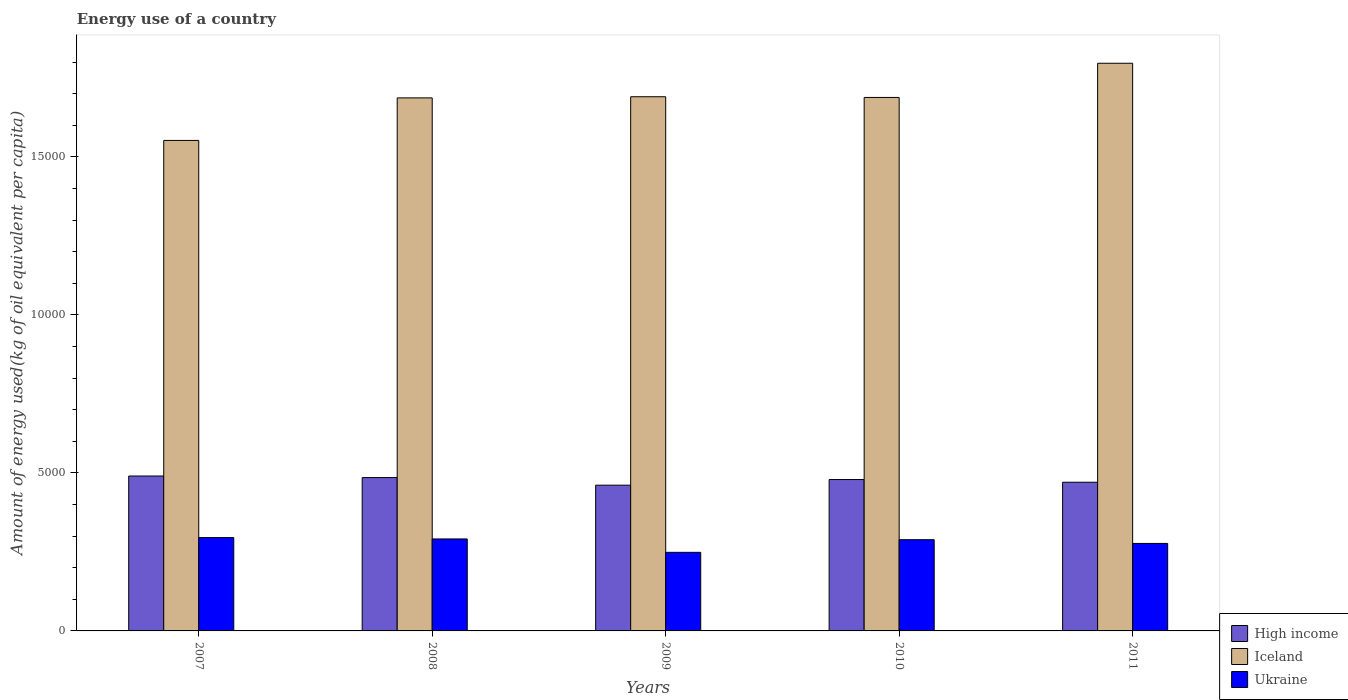How many different coloured bars are there?
Your response must be concise. 3. How many groups of bars are there?
Ensure brevity in your answer.  5. What is the label of the 1st group of bars from the left?
Offer a terse response. 2007. What is the amount of energy used in in High income in 2010?
Give a very brief answer. 4790.88. Across all years, what is the maximum amount of energy used in in High income?
Ensure brevity in your answer.  4902.25. Across all years, what is the minimum amount of energy used in in High income?
Provide a succinct answer. 4612.03. What is the total amount of energy used in in Ukraine in the graph?
Give a very brief answer. 1.40e+04. What is the difference between the amount of energy used in in High income in 2007 and that in 2010?
Provide a short and direct response. 111.37. What is the difference between the amount of energy used in in Iceland in 2011 and the amount of energy used in in Ukraine in 2007?
Make the answer very short. 1.50e+04. What is the average amount of energy used in in Ukraine per year?
Your answer should be very brief. 2801.32. In the year 2008, what is the difference between the amount of energy used in in High income and amount of energy used in in Ukraine?
Give a very brief answer. 1942.06. In how many years, is the amount of energy used in in High income greater than 15000 kg?
Provide a short and direct response. 0. What is the ratio of the amount of energy used in in High income in 2008 to that in 2011?
Make the answer very short. 1.03. Is the amount of energy used in in Iceland in 2007 less than that in 2010?
Your answer should be very brief. Yes. What is the difference between the highest and the second highest amount of energy used in in High income?
Provide a short and direct response. 49.54. What is the difference between the highest and the lowest amount of energy used in in Iceland?
Give a very brief answer. 2442.29. Is the sum of the amount of energy used in in Iceland in 2010 and 2011 greater than the maximum amount of energy used in in Ukraine across all years?
Your answer should be very brief. Yes. What does the 2nd bar from the left in 2009 represents?
Provide a short and direct response. Iceland. What does the 3rd bar from the right in 2009 represents?
Offer a very short reply. High income. Is it the case that in every year, the sum of the amount of energy used in in Ukraine and amount of energy used in in Iceland is greater than the amount of energy used in in High income?
Give a very brief answer. Yes. How many bars are there?
Give a very brief answer. 15. Are all the bars in the graph horizontal?
Your response must be concise. No. What is the difference between two consecutive major ticks on the Y-axis?
Provide a short and direct response. 5000. Are the values on the major ticks of Y-axis written in scientific E-notation?
Your answer should be compact. No. What is the title of the graph?
Ensure brevity in your answer.  Energy use of a country. What is the label or title of the Y-axis?
Offer a very short reply. Amount of energy used(kg of oil equivalent per capita). What is the Amount of energy used(kg of oil equivalent per capita) in High income in 2007?
Your answer should be very brief. 4902.25. What is the Amount of energy used(kg of oil equivalent per capita) in Iceland in 2007?
Keep it short and to the point. 1.55e+04. What is the Amount of energy used(kg of oil equivalent per capita) in Ukraine in 2007?
Your answer should be compact. 2953.02. What is the Amount of energy used(kg of oil equivalent per capita) of High income in 2008?
Provide a short and direct response. 4852.71. What is the Amount of energy used(kg of oil equivalent per capita) in Iceland in 2008?
Provide a short and direct response. 1.69e+04. What is the Amount of energy used(kg of oil equivalent per capita) of Ukraine in 2008?
Your answer should be very brief. 2910.65. What is the Amount of energy used(kg of oil equivalent per capita) in High income in 2009?
Offer a terse response. 4612.03. What is the Amount of energy used(kg of oil equivalent per capita) of Iceland in 2009?
Your response must be concise. 1.69e+04. What is the Amount of energy used(kg of oil equivalent per capita) in Ukraine in 2009?
Offer a terse response. 2487.04. What is the Amount of energy used(kg of oil equivalent per capita) of High income in 2010?
Keep it short and to the point. 4790.88. What is the Amount of energy used(kg of oil equivalent per capita) of Iceland in 2010?
Your response must be concise. 1.69e+04. What is the Amount of energy used(kg of oil equivalent per capita) in Ukraine in 2010?
Make the answer very short. 2887. What is the Amount of energy used(kg of oil equivalent per capita) of High income in 2011?
Provide a short and direct response. 4705.29. What is the Amount of energy used(kg of oil equivalent per capita) in Iceland in 2011?
Keep it short and to the point. 1.80e+04. What is the Amount of energy used(kg of oil equivalent per capita) of Ukraine in 2011?
Your response must be concise. 2768.92. Across all years, what is the maximum Amount of energy used(kg of oil equivalent per capita) in High income?
Your answer should be very brief. 4902.25. Across all years, what is the maximum Amount of energy used(kg of oil equivalent per capita) in Iceland?
Provide a succinct answer. 1.80e+04. Across all years, what is the maximum Amount of energy used(kg of oil equivalent per capita) of Ukraine?
Provide a succinct answer. 2953.02. Across all years, what is the minimum Amount of energy used(kg of oil equivalent per capita) in High income?
Your response must be concise. 4612.03. Across all years, what is the minimum Amount of energy used(kg of oil equivalent per capita) of Iceland?
Provide a succinct answer. 1.55e+04. Across all years, what is the minimum Amount of energy used(kg of oil equivalent per capita) of Ukraine?
Make the answer very short. 2487.04. What is the total Amount of energy used(kg of oil equivalent per capita) of High income in the graph?
Provide a short and direct response. 2.39e+04. What is the total Amount of energy used(kg of oil equivalent per capita) of Iceland in the graph?
Provide a succinct answer. 8.41e+04. What is the total Amount of energy used(kg of oil equivalent per capita) of Ukraine in the graph?
Provide a short and direct response. 1.40e+04. What is the difference between the Amount of energy used(kg of oil equivalent per capita) of High income in 2007 and that in 2008?
Your response must be concise. 49.54. What is the difference between the Amount of energy used(kg of oil equivalent per capita) of Iceland in 2007 and that in 2008?
Offer a terse response. -1346.32. What is the difference between the Amount of energy used(kg of oil equivalent per capita) of Ukraine in 2007 and that in 2008?
Your answer should be very brief. 42.36. What is the difference between the Amount of energy used(kg of oil equivalent per capita) of High income in 2007 and that in 2009?
Your answer should be compact. 290.21. What is the difference between the Amount of energy used(kg of oil equivalent per capita) in Iceland in 2007 and that in 2009?
Offer a very short reply. -1382.75. What is the difference between the Amount of energy used(kg of oil equivalent per capita) in Ukraine in 2007 and that in 2009?
Your answer should be very brief. 465.98. What is the difference between the Amount of energy used(kg of oil equivalent per capita) of High income in 2007 and that in 2010?
Offer a very short reply. 111.37. What is the difference between the Amount of energy used(kg of oil equivalent per capita) in Iceland in 2007 and that in 2010?
Your answer should be very brief. -1360.35. What is the difference between the Amount of energy used(kg of oil equivalent per capita) in Ukraine in 2007 and that in 2010?
Provide a short and direct response. 66.02. What is the difference between the Amount of energy used(kg of oil equivalent per capita) in High income in 2007 and that in 2011?
Provide a short and direct response. 196.96. What is the difference between the Amount of energy used(kg of oil equivalent per capita) in Iceland in 2007 and that in 2011?
Your response must be concise. -2442.29. What is the difference between the Amount of energy used(kg of oil equivalent per capita) of Ukraine in 2007 and that in 2011?
Give a very brief answer. 184.09. What is the difference between the Amount of energy used(kg of oil equivalent per capita) of High income in 2008 and that in 2009?
Your answer should be very brief. 240.68. What is the difference between the Amount of energy used(kg of oil equivalent per capita) of Iceland in 2008 and that in 2009?
Provide a short and direct response. -36.44. What is the difference between the Amount of energy used(kg of oil equivalent per capita) in Ukraine in 2008 and that in 2009?
Provide a short and direct response. 423.61. What is the difference between the Amount of energy used(kg of oil equivalent per capita) in High income in 2008 and that in 2010?
Your answer should be very brief. 61.83. What is the difference between the Amount of energy used(kg of oil equivalent per capita) in Iceland in 2008 and that in 2010?
Give a very brief answer. -14.03. What is the difference between the Amount of energy used(kg of oil equivalent per capita) of Ukraine in 2008 and that in 2010?
Keep it short and to the point. 23.66. What is the difference between the Amount of energy used(kg of oil equivalent per capita) of High income in 2008 and that in 2011?
Your answer should be compact. 147.42. What is the difference between the Amount of energy used(kg of oil equivalent per capita) of Iceland in 2008 and that in 2011?
Offer a terse response. -1095.98. What is the difference between the Amount of energy used(kg of oil equivalent per capita) of Ukraine in 2008 and that in 2011?
Provide a succinct answer. 141.73. What is the difference between the Amount of energy used(kg of oil equivalent per capita) in High income in 2009 and that in 2010?
Your answer should be compact. -178.84. What is the difference between the Amount of energy used(kg of oil equivalent per capita) in Iceland in 2009 and that in 2010?
Offer a very short reply. 22.4. What is the difference between the Amount of energy used(kg of oil equivalent per capita) of Ukraine in 2009 and that in 2010?
Give a very brief answer. -399.96. What is the difference between the Amount of energy used(kg of oil equivalent per capita) in High income in 2009 and that in 2011?
Give a very brief answer. -93.26. What is the difference between the Amount of energy used(kg of oil equivalent per capita) of Iceland in 2009 and that in 2011?
Make the answer very short. -1059.54. What is the difference between the Amount of energy used(kg of oil equivalent per capita) of Ukraine in 2009 and that in 2011?
Your response must be concise. -281.89. What is the difference between the Amount of energy used(kg of oil equivalent per capita) of High income in 2010 and that in 2011?
Provide a succinct answer. 85.58. What is the difference between the Amount of energy used(kg of oil equivalent per capita) of Iceland in 2010 and that in 2011?
Your response must be concise. -1081.94. What is the difference between the Amount of energy used(kg of oil equivalent per capita) of Ukraine in 2010 and that in 2011?
Ensure brevity in your answer.  118.07. What is the difference between the Amount of energy used(kg of oil equivalent per capita) in High income in 2007 and the Amount of energy used(kg of oil equivalent per capita) in Iceland in 2008?
Offer a terse response. -1.20e+04. What is the difference between the Amount of energy used(kg of oil equivalent per capita) of High income in 2007 and the Amount of energy used(kg of oil equivalent per capita) of Ukraine in 2008?
Give a very brief answer. 1991.59. What is the difference between the Amount of energy used(kg of oil equivalent per capita) in Iceland in 2007 and the Amount of energy used(kg of oil equivalent per capita) in Ukraine in 2008?
Your response must be concise. 1.26e+04. What is the difference between the Amount of energy used(kg of oil equivalent per capita) in High income in 2007 and the Amount of energy used(kg of oil equivalent per capita) in Iceland in 2009?
Ensure brevity in your answer.  -1.20e+04. What is the difference between the Amount of energy used(kg of oil equivalent per capita) in High income in 2007 and the Amount of energy used(kg of oil equivalent per capita) in Ukraine in 2009?
Your answer should be compact. 2415.21. What is the difference between the Amount of energy used(kg of oil equivalent per capita) of Iceland in 2007 and the Amount of energy used(kg of oil equivalent per capita) of Ukraine in 2009?
Provide a succinct answer. 1.30e+04. What is the difference between the Amount of energy used(kg of oil equivalent per capita) of High income in 2007 and the Amount of energy used(kg of oil equivalent per capita) of Iceland in 2010?
Ensure brevity in your answer.  -1.20e+04. What is the difference between the Amount of energy used(kg of oil equivalent per capita) in High income in 2007 and the Amount of energy used(kg of oil equivalent per capita) in Ukraine in 2010?
Your answer should be very brief. 2015.25. What is the difference between the Amount of energy used(kg of oil equivalent per capita) of Iceland in 2007 and the Amount of energy used(kg of oil equivalent per capita) of Ukraine in 2010?
Your answer should be compact. 1.26e+04. What is the difference between the Amount of energy used(kg of oil equivalent per capita) in High income in 2007 and the Amount of energy used(kg of oil equivalent per capita) in Iceland in 2011?
Provide a succinct answer. -1.31e+04. What is the difference between the Amount of energy used(kg of oil equivalent per capita) of High income in 2007 and the Amount of energy used(kg of oil equivalent per capita) of Ukraine in 2011?
Offer a very short reply. 2133.32. What is the difference between the Amount of energy used(kg of oil equivalent per capita) of Iceland in 2007 and the Amount of energy used(kg of oil equivalent per capita) of Ukraine in 2011?
Provide a succinct answer. 1.28e+04. What is the difference between the Amount of energy used(kg of oil equivalent per capita) of High income in 2008 and the Amount of energy used(kg of oil equivalent per capita) of Iceland in 2009?
Your answer should be compact. -1.21e+04. What is the difference between the Amount of energy used(kg of oil equivalent per capita) in High income in 2008 and the Amount of energy used(kg of oil equivalent per capita) in Ukraine in 2009?
Your answer should be very brief. 2365.67. What is the difference between the Amount of energy used(kg of oil equivalent per capita) of Iceland in 2008 and the Amount of energy used(kg of oil equivalent per capita) of Ukraine in 2009?
Give a very brief answer. 1.44e+04. What is the difference between the Amount of energy used(kg of oil equivalent per capita) in High income in 2008 and the Amount of energy used(kg of oil equivalent per capita) in Iceland in 2010?
Your answer should be compact. -1.20e+04. What is the difference between the Amount of energy used(kg of oil equivalent per capita) in High income in 2008 and the Amount of energy used(kg of oil equivalent per capita) in Ukraine in 2010?
Your answer should be compact. 1965.71. What is the difference between the Amount of energy used(kg of oil equivalent per capita) of Iceland in 2008 and the Amount of energy used(kg of oil equivalent per capita) of Ukraine in 2010?
Your response must be concise. 1.40e+04. What is the difference between the Amount of energy used(kg of oil equivalent per capita) of High income in 2008 and the Amount of energy used(kg of oil equivalent per capita) of Iceland in 2011?
Offer a terse response. -1.31e+04. What is the difference between the Amount of energy used(kg of oil equivalent per capita) of High income in 2008 and the Amount of energy used(kg of oil equivalent per capita) of Ukraine in 2011?
Your response must be concise. 2083.78. What is the difference between the Amount of energy used(kg of oil equivalent per capita) of Iceland in 2008 and the Amount of energy used(kg of oil equivalent per capita) of Ukraine in 2011?
Provide a short and direct response. 1.41e+04. What is the difference between the Amount of energy used(kg of oil equivalent per capita) in High income in 2009 and the Amount of energy used(kg of oil equivalent per capita) in Iceland in 2010?
Ensure brevity in your answer.  -1.23e+04. What is the difference between the Amount of energy used(kg of oil equivalent per capita) in High income in 2009 and the Amount of energy used(kg of oil equivalent per capita) in Ukraine in 2010?
Give a very brief answer. 1725.03. What is the difference between the Amount of energy used(kg of oil equivalent per capita) of Iceland in 2009 and the Amount of energy used(kg of oil equivalent per capita) of Ukraine in 2010?
Your answer should be very brief. 1.40e+04. What is the difference between the Amount of energy used(kg of oil equivalent per capita) in High income in 2009 and the Amount of energy used(kg of oil equivalent per capita) in Iceland in 2011?
Give a very brief answer. -1.34e+04. What is the difference between the Amount of energy used(kg of oil equivalent per capita) in High income in 2009 and the Amount of energy used(kg of oil equivalent per capita) in Ukraine in 2011?
Your answer should be very brief. 1843.11. What is the difference between the Amount of energy used(kg of oil equivalent per capita) of Iceland in 2009 and the Amount of energy used(kg of oil equivalent per capita) of Ukraine in 2011?
Give a very brief answer. 1.41e+04. What is the difference between the Amount of energy used(kg of oil equivalent per capita) of High income in 2010 and the Amount of energy used(kg of oil equivalent per capita) of Iceland in 2011?
Offer a terse response. -1.32e+04. What is the difference between the Amount of energy used(kg of oil equivalent per capita) in High income in 2010 and the Amount of energy used(kg of oil equivalent per capita) in Ukraine in 2011?
Offer a terse response. 2021.95. What is the difference between the Amount of energy used(kg of oil equivalent per capita) in Iceland in 2010 and the Amount of energy used(kg of oil equivalent per capita) in Ukraine in 2011?
Provide a succinct answer. 1.41e+04. What is the average Amount of energy used(kg of oil equivalent per capita) in High income per year?
Offer a terse response. 4772.63. What is the average Amount of energy used(kg of oil equivalent per capita) in Iceland per year?
Offer a terse response. 1.68e+04. What is the average Amount of energy used(kg of oil equivalent per capita) in Ukraine per year?
Offer a very short reply. 2801.32. In the year 2007, what is the difference between the Amount of energy used(kg of oil equivalent per capita) of High income and Amount of energy used(kg of oil equivalent per capita) of Iceland?
Provide a succinct answer. -1.06e+04. In the year 2007, what is the difference between the Amount of energy used(kg of oil equivalent per capita) of High income and Amount of energy used(kg of oil equivalent per capita) of Ukraine?
Provide a succinct answer. 1949.23. In the year 2007, what is the difference between the Amount of energy used(kg of oil equivalent per capita) in Iceland and Amount of energy used(kg of oil equivalent per capita) in Ukraine?
Offer a terse response. 1.26e+04. In the year 2008, what is the difference between the Amount of energy used(kg of oil equivalent per capita) of High income and Amount of energy used(kg of oil equivalent per capita) of Iceland?
Make the answer very short. -1.20e+04. In the year 2008, what is the difference between the Amount of energy used(kg of oil equivalent per capita) in High income and Amount of energy used(kg of oil equivalent per capita) in Ukraine?
Provide a succinct answer. 1942.06. In the year 2008, what is the difference between the Amount of energy used(kg of oil equivalent per capita) of Iceland and Amount of energy used(kg of oil equivalent per capita) of Ukraine?
Your answer should be compact. 1.40e+04. In the year 2009, what is the difference between the Amount of energy used(kg of oil equivalent per capita) of High income and Amount of energy used(kg of oil equivalent per capita) of Iceland?
Make the answer very short. -1.23e+04. In the year 2009, what is the difference between the Amount of energy used(kg of oil equivalent per capita) in High income and Amount of energy used(kg of oil equivalent per capita) in Ukraine?
Offer a terse response. 2124.99. In the year 2009, what is the difference between the Amount of energy used(kg of oil equivalent per capita) of Iceland and Amount of energy used(kg of oil equivalent per capita) of Ukraine?
Offer a terse response. 1.44e+04. In the year 2010, what is the difference between the Amount of energy used(kg of oil equivalent per capita) in High income and Amount of energy used(kg of oil equivalent per capita) in Iceland?
Provide a short and direct response. -1.21e+04. In the year 2010, what is the difference between the Amount of energy used(kg of oil equivalent per capita) in High income and Amount of energy used(kg of oil equivalent per capita) in Ukraine?
Give a very brief answer. 1903.88. In the year 2010, what is the difference between the Amount of energy used(kg of oil equivalent per capita) of Iceland and Amount of energy used(kg of oil equivalent per capita) of Ukraine?
Give a very brief answer. 1.40e+04. In the year 2011, what is the difference between the Amount of energy used(kg of oil equivalent per capita) of High income and Amount of energy used(kg of oil equivalent per capita) of Iceland?
Your answer should be compact. -1.33e+04. In the year 2011, what is the difference between the Amount of energy used(kg of oil equivalent per capita) in High income and Amount of energy used(kg of oil equivalent per capita) in Ukraine?
Give a very brief answer. 1936.37. In the year 2011, what is the difference between the Amount of energy used(kg of oil equivalent per capita) of Iceland and Amount of energy used(kg of oil equivalent per capita) of Ukraine?
Offer a very short reply. 1.52e+04. What is the ratio of the Amount of energy used(kg of oil equivalent per capita) in High income in 2007 to that in 2008?
Your response must be concise. 1.01. What is the ratio of the Amount of energy used(kg of oil equivalent per capita) of Iceland in 2007 to that in 2008?
Ensure brevity in your answer.  0.92. What is the ratio of the Amount of energy used(kg of oil equivalent per capita) in Ukraine in 2007 to that in 2008?
Offer a very short reply. 1.01. What is the ratio of the Amount of energy used(kg of oil equivalent per capita) of High income in 2007 to that in 2009?
Give a very brief answer. 1.06. What is the ratio of the Amount of energy used(kg of oil equivalent per capita) in Iceland in 2007 to that in 2009?
Ensure brevity in your answer.  0.92. What is the ratio of the Amount of energy used(kg of oil equivalent per capita) in Ukraine in 2007 to that in 2009?
Ensure brevity in your answer.  1.19. What is the ratio of the Amount of energy used(kg of oil equivalent per capita) in High income in 2007 to that in 2010?
Your response must be concise. 1.02. What is the ratio of the Amount of energy used(kg of oil equivalent per capita) of Iceland in 2007 to that in 2010?
Your answer should be compact. 0.92. What is the ratio of the Amount of energy used(kg of oil equivalent per capita) of Ukraine in 2007 to that in 2010?
Provide a succinct answer. 1.02. What is the ratio of the Amount of energy used(kg of oil equivalent per capita) in High income in 2007 to that in 2011?
Your response must be concise. 1.04. What is the ratio of the Amount of energy used(kg of oil equivalent per capita) in Iceland in 2007 to that in 2011?
Your answer should be very brief. 0.86. What is the ratio of the Amount of energy used(kg of oil equivalent per capita) in Ukraine in 2007 to that in 2011?
Provide a succinct answer. 1.07. What is the ratio of the Amount of energy used(kg of oil equivalent per capita) of High income in 2008 to that in 2009?
Your response must be concise. 1.05. What is the ratio of the Amount of energy used(kg of oil equivalent per capita) in Iceland in 2008 to that in 2009?
Keep it short and to the point. 1. What is the ratio of the Amount of energy used(kg of oil equivalent per capita) in Ukraine in 2008 to that in 2009?
Your response must be concise. 1.17. What is the ratio of the Amount of energy used(kg of oil equivalent per capita) in High income in 2008 to that in 2010?
Give a very brief answer. 1.01. What is the ratio of the Amount of energy used(kg of oil equivalent per capita) of Ukraine in 2008 to that in 2010?
Keep it short and to the point. 1.01. What is the ratio of the Amount of energy used(kg of oil equivalent per capita) in High income in 2008 to that in 2011?
Keep it short and to the point. 1.03. What is the ratio of the Amount of energy used(kg of oil equivalent per capita) in Iceland in 2008 to that in 2011?
Make the answer very short. 0.94. What is the ratio of the Amount of energy used(kg of oil equivalent per capita) of Ukraine in 2008 to that in 2011?
Keep it short and to the point. 1.05. What is the ratio of the Amount of energy used(kg of oil equivalent per capita) in High income in 2009 to that in 2010?
Ensure brevity in your answer.  0.96. What is the ratio of the Amount of energy used(kg of oil equivalent per capita) in Ukraine in 2009 to that in 2010?
Your answer should be very brief. 0.86. What is the ratio of the Amount of energy used(kg of oil equivalent per capita) of High income in 2009 to that in 2011?
Your answer should be very brief. 0.98. What is the ratio of the Amount of energy used(kg of oil equivalent per capita) of Iceland in 2009 to that in 2011?
Offer a terse response. 0.94. What is the ratio of the Amount of energy used(kg of oil equivalent per capita) in Ukraine in 2009 to that in 2011?
Your answer should be very brief. 0.9. What is the ratio of the Amount of energy used(kg of oil equivalent per capita) of High income in 2010 to that in 2011?
Offer a very short reply. 1.02. What is the ratio of the Amount of energy used(kg of oil equivalent per capita) of Iceland in 2010 to that in 2011?
Ensure brevity in your answer.  0.94. What is the ratio of the Amount of energy used(kg of oil equivalent per capita) of Ukraine in 2010 to that in 2011?
Ensure brevity in your answer.  1.04. What is the difference between the highest and the second highest Amount of energy used(kg of oil equivalent per capita) of High income?
Your answer should be compact. 49.54. What is the difference between the highest and the second highest Amount of energy used(kg of oil equivalent per capita) in Iceland?
Provide a succinct answer. 1059.54. What is the difference between the highest and the second highest Amount of energy used(kg of oil equivalent per capita) of Ukraine?
Provide a short and direct response. 42.36. What is the difference between the highest and the lowest Amount of energy used(kg of oil equivalent per capita) in High income?
Make the answer very short. 290.21. What is the difference between the highest and the lowest Amount of energy used(kg of oil equivalent per capita) in Iceland?
Give a very brief answer. 2442.29. What is the difference between the highest and the lowest Amount of energy used(kg of oil equivalent per capita) of Ukraine?
Offer a terse response. 465.98. 